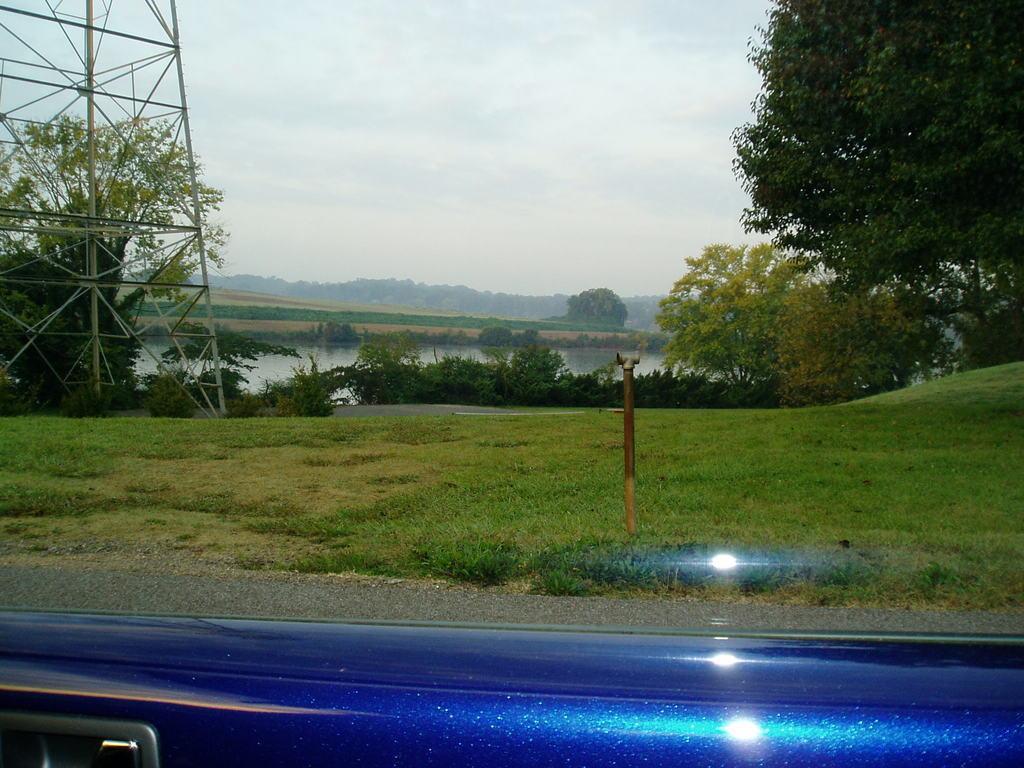How would you summarize this image in a sentence or two? This picture is taken from a vehicle. I can see trees, a tower, few plants and grass on the ground and I can see a cloudy sky. 